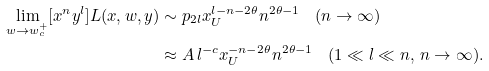Convert formula to latex. <formula><loc_0><loc_0><loc_500><loc_500>\lim _ { w \to w _ { c } ^ { + } } [ x ^ { n } y ^ { l } ] L ( x , w , y ) & \sim p _ { 2 l } x _ { U } ^ { l - n - 2 \theta } n ^ { 2 \theta - 1 } \quad ( n \to \infty ) \\ & \approx A \, l ^ { - c } x _ { U } ^ { - n - 2 \theta } n ^ { 2 \theta - 1 } \quad ( 1 \ll l \ll n , \, n \to \infty ) .</formula> 